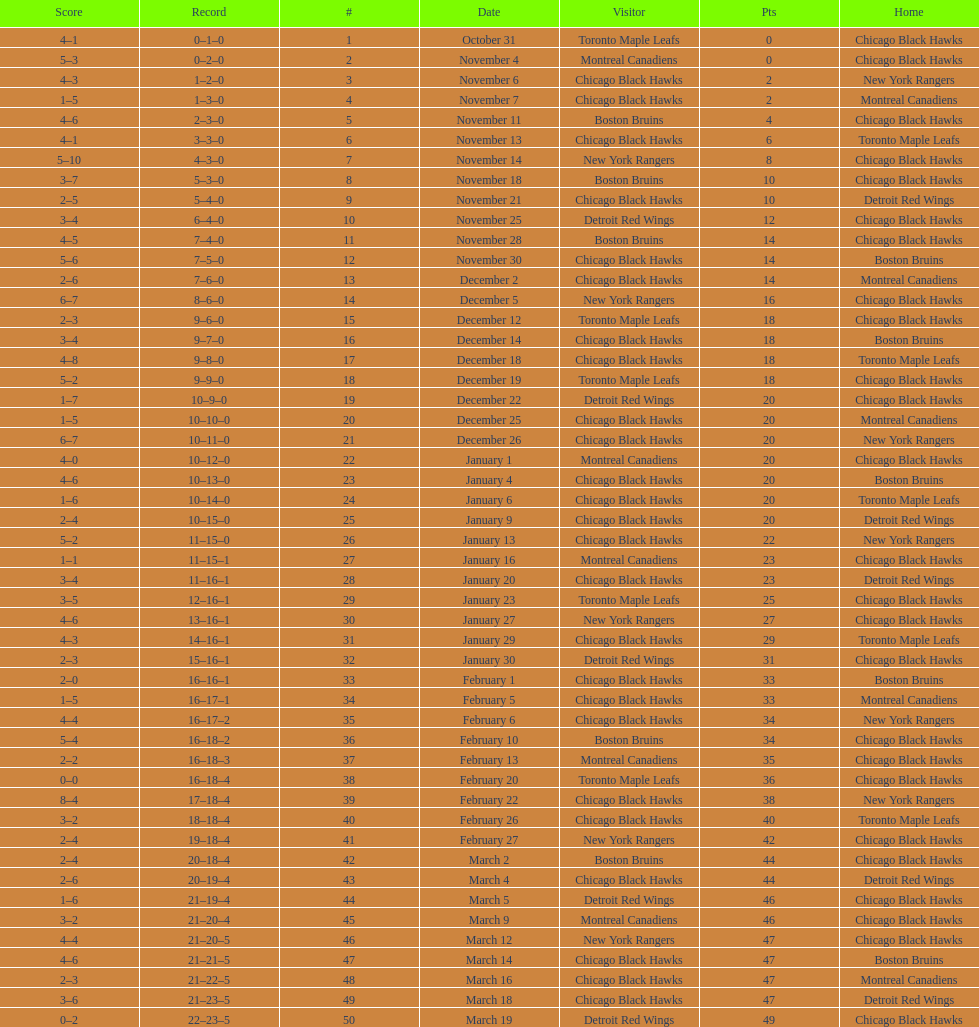On december 14 was the home team the chicago black hawks or the boston bruins? Boston Bruins. 